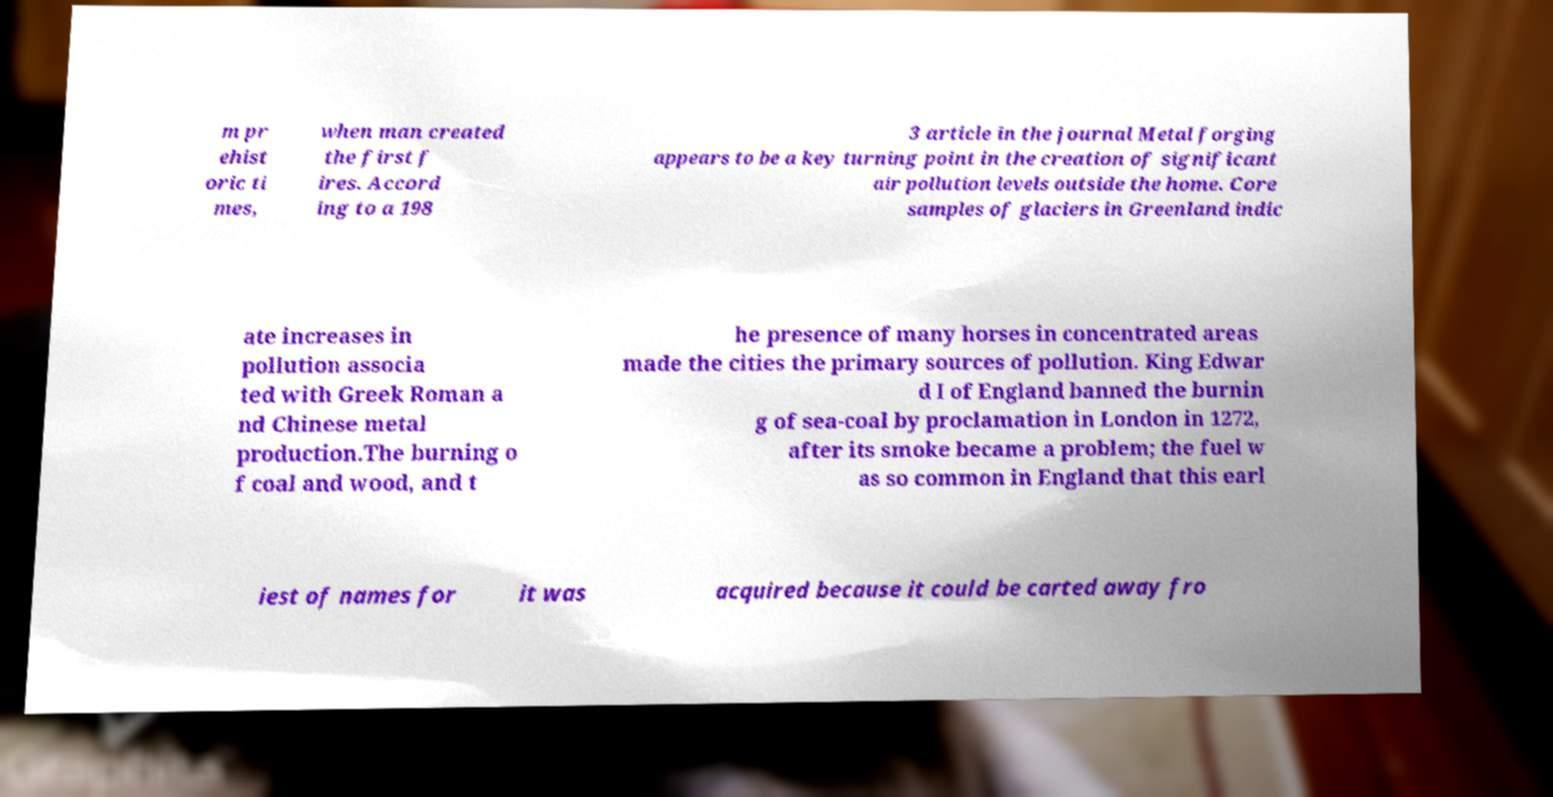For documentation purposes, I need the text within this image transcribed. Could you provide that? m pr ehist oric ti mes, when man created the first f ires. Accord ing to a 198 3 article in the journal Metal forging appears to be a key turning point in the creation of significant air pollution levels outside the home. Core samples of glaciers in Greenland indic ate increases in pollution associa ted with Greek Roman a nd Chinese metal production.The burning o f coal and wood, and t he presence of many horses in concentrated areas made the cities the primary sources of pollution. King Edwar d I of England banned the burnin g of sea-coal by proclamation in London in 1272, after its smoke became a problem; the fuel w as so common in England that this earl iest of names for it was acquired because it could be carted away fro 